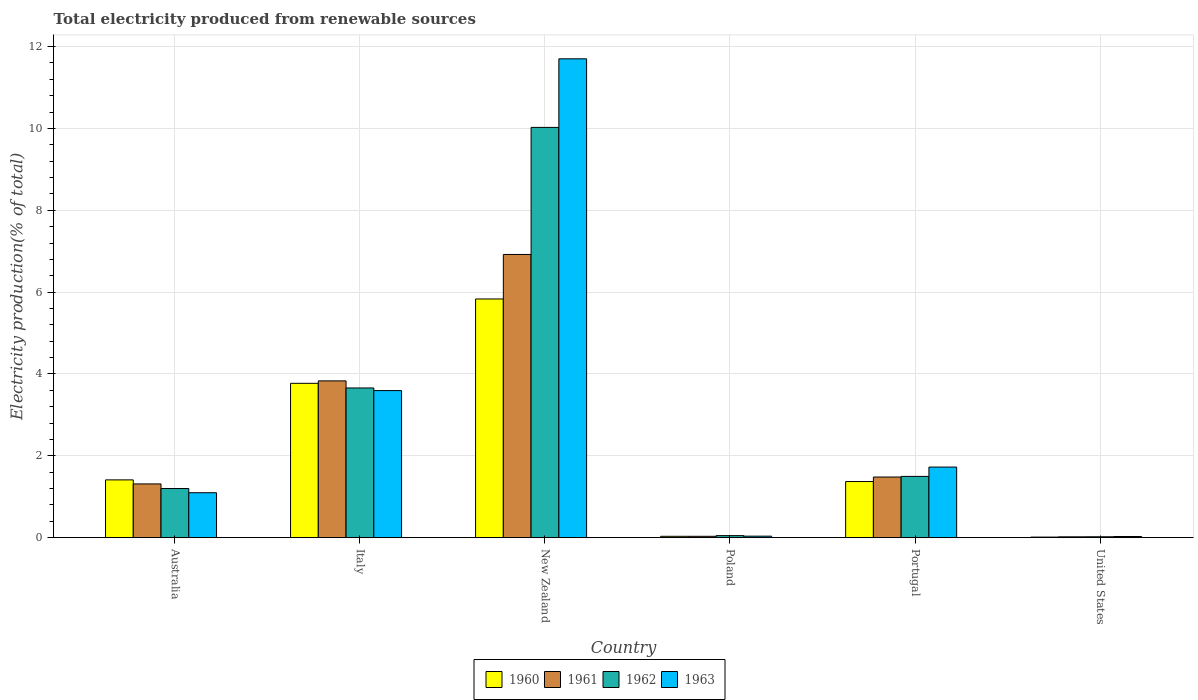How many groups of bars are there?
Make the answer very short. 6. Are the number of bars on each tick of the X-axis equal?
Ensure brevity in your answer.  Yes. How many bars are there on the 5th tick from the left?
Provide a short and direct response. 4. How many bars are there on the 2nd tick from the right?
Your response must be concise. 4. What is the label of the 4th group of bars from the left?
Your answer should be compact. Poland. What is the total electricity produced in 1962 in Poland?
Provide a short and direct response. 0.05. Across all countries, what is the maximum total electricity produced in 1963?
Make the answer very short. 11.7. Across all countries, what is the minimum total electricity produced in 1960?
Offer a terse response. 0.02. In which country was the total electricity produced in 1960 maximum?
Offer a terse response. New Zealand. In which country was the total electricity produced in 1960 minimum?
Keep it short and to the point. United States. What is the total total electricity produced in 1961 in the graph?
Keep it short and to the point. 13.6. What is the difference between the total electricity produced in 1963 in Australia and that in United States?
Offer a very short reply. 1.07. What is the difference between the total electricity produced in 1960 in Australia and the total electricity produced in 1962 in Poland?
Offer a terse response. 1.36. What is the average total electricity produced in 1961 per country?
Offer a terse response. 2.27. What is the difference between the total electricity produced of/in 1962 and total electricity produced of/in 1961 in Poland?
Your answer should be compact. 0.02. What is the ratio of the total electricity produced in 1963 in Italy to that in New Zealand?
Provide a short and direct response. 0.31. Is the total electricity produced in 1963 in Australia less than that in New Zealand?
Give a very brief answer. Yes. What is the difference between the highest and the second highest total electricity produced in 1963?
Provide a succinct answer. 1.87. What is the difference between the highest and the lowest total electricity produced in 1961?
Provide a short and direct response. 6.9. In how many countries, is the total electricity produced in 1963 greater than the average total electricity produced in 1963 taken over all countries?
Your answer should be compact. 2. Is it the case that in every country, the sum of the total electricity produced in 1963 and total electricity produced in 1961 is greater than the sum of total electricity produced in 1962 and total electricity produced in 1960?
Your response must be concise. No. How many bars are there?
Your response must be concise. 24. Are all the bars in the graph horizontal?
Provide a short and direct response. No. Does the graph contain any zero values?
Your answer should be very brief. No. What is the title of the graph?
Provide a succinct answer. Total electricity produced from renewable sources. Does "1993" appear as one of the legend labels in the graph?
Make the answer very short. No. What is the label or title of the Y-axis?
Ensure brevity in your answer.  Electricity production(% of total). What is the Electricity production(% of total) in 1960 in Australia?
Give a very brief answer. 1.41. What is the Electricity production(% of total) of 1961 in Australia?
Your answer should be compact. 1.31. What is the Electricity production(% of total) in 1962 in Australia?
Keep it short and to the point. 1.2. What is the Electricity production(% of total) of 1963 in Australia?
Give a very brief answer. 1.1. What is the Electricity production(% of total) in 1960 in Italy?
Keep it short and to the point. 3.77. What is the Electricity production(% of total) in 1961 in Italy?
Ensure brevity in your answer.  3.83. What is the Electricity production(% of total) in 1962 in Italy?
Your answer should be very brief. 3.66. What is the Electricity production(% of total) in 1963 in Italy?
Your response must be concise. 3.59. What is the Electricity production(% of total) in 1960 in New Zealand?
Keep it short and to the point. 5.83. What is the Electricity production(% of total) of 1961 in New Zealand?
Your answer should be compact. 6.92. What is the Electricity production(% of total) in 1962 in New Zealand?
Your answer should be compact. 10.02. What is the Electricity production(% of total) in 1963 in New Zealand?
Your response must be concise. 11.7. What is the Electricity production(% of total) in 1960 in Poland?
Provide a short and direct response. 0.03. What is the Electricity production(% of total) in 1961 in Poland?
Offer a very short reply. 0.03. What is the Electricity production(% of total) in 1962 in Poland?
Ensure brevity in your answer.  0.05. What is the Electricity production(% of total) in 1963 in Poland?
Ensure brevity in your answer.  0.04. What is the Electricity production(% of total) of 1960 in Portugal?
Your answer should be very brief. 1.37. What is the Electricity production(% of total) of 1961 in Portugal?
Ensure brevity in your answer.  1.48. What is the Electricity production(% of total) in 1962 in Portugal?
Your answer should be very brief. 1.5. What is the Electricity production(% of total) in 1963 in Portugal?
Your answer should be compact. 1.73. What is the Electricity production(% of total) of 1960 in United States?
Give a very brief answer. 0.02. What is the Electricity production(% of total) in 1961 in United States?
Your response must be concise. 0.02. What is the Electricity production(% of total) of 1962 in United States?
Offer a very short reply. 0.02. What is the Electricity production(% of total) of 1963 in United States?
Keep it short and to the point. 0.03. Across all countries, what is the maximum Electricity production(% of total) in 1960?
Your answer should be compact. 5.83. Across all countries, what is the maximum Electricity production(% of total) of 1961?
Keep it short and to the point. 6.92. Across all countries, what is the maximum Electricity production(% of total) in 1962?
Ensure brevity in your answer.  10.02. Across all countries, what is the maximum Electricity production(% of total) in 1963?
Your answer should be very brief. 11.7. Across all countries, what is the minimum Electricity production(% of total) of 1960?
Keep it short and to the point. 0.02. Across all countries, what is the minimum Electricity production(% of total) of 1961?
Ensure brevity in your answer.  0.02. Across all countries, what is the minimum Electricity production(% of total) of 1962?
Give a very brief answer. 0.02. Across all countries, what is the minimum Electricity production(% of total) of 1963?
Your answer should be very brief. 0.03. What is the total Electricity production(% of total) of 1960 in the graph?
Provide a succinct answer. 12.44. What is the total Electricity production(% of total) in 1961 in the graph?
Your response must be concise. 13.6. What is the total Electricity production(% of total) of 1962 in the graph?
Offer a terse response. 16.46. What is the total Electricity production(% of total) in 1963 in the graph?
Your response must be concise. 18.19. What is the difference between the Electricity production(% of total) in 1960 in Australia and that in Italy?
Provide a succinct answer. -2.36. What is the difference between the Electricity production(% of total) in 1961 in Australia and that in Italy?
Provide a short and direct response. -2.52. What is the difference between the Electricity production(% of total) of 1962 in Australia and that in Italy?
Your answer should be very brief. -2.46. What is the difference between the Electricity production(% of total) in 1963 in Australia and that in Italy?
Offer a terse response. -2.5. What is the difference between the Electricity production(% of total) of 1960 in Australia and that in New Zealand?
Your answer should be compact. -4.42. What is the difference between the Electricity production(% of total) of 1961 in Australia and that in New Zealand?
Ensure brevity in your answer.  -5.61. What is the difference between the Electricity production(% of total) in 1962 in Australia and that in New Zealand?
Provide a succinct answer. -8.82. What is the difference between the Electricity production(% of total) in 1963 in Australia and that in New Zealand?
Provide a short and direct response. -10.6. What is the difference between the Electricity production(% of total) in 1960 in Australia and that in Poland?
Your response must be concise. 1.38. What is the difference between the Electricity production(% of total) of 1961 in Australia and that in Poland?
Give a very brief answer. 1.28. What is the difference between the Electricity production(% of total) in 1962 in Australia and that in Poland?
Your answer should be compact. 1.15. What is the difference between the Electricity production(% of total) of 1963 in Australia and that in Poland?
Your answer should be compact. 1.06. What is the difference between the Electricity production(% of total) in 1960 in Australia and that in Portugal?
Give a very brief answer. 0.04. What is the difference between the Electricity production(% of total) in 1961 in Australia and that in Portugal?
Provide a succinct answer. -0.17. What is the difference between the Electricity production(% of total) in 1962 in Australia and that in Portugal?
Provide a succinct answer. -0.3. What is the difference between the Electricity production(% of total) in 1963 in Australia and that in Portugal?
Your answer should be compact. -0.63. What is the difference between the Electricity production(% of total) of 1960 in Australia and that in United States?
Keep it short and to the point. 1.4. What is the difference between the Electricity production(% of total) in 1961 in Australia and that in United States?
Your response must be concise. 1.29. What is the difference between the Electricity production(% of total) in 1962 in Australia and that in United States?
Offer a terse response. 1.18. What is the difference between the Electricity production(% of total) of 1963 in Australia and that in United States?
Offer a very short reply. 1.07. What is the difference between the Electricity production(% of total) in 1960 in Italy and that in New Zealand?
Provide a succinct answer. -2.06. What is the difference between the Electricity production(% of total) in 1961 in Italy and that in New Zealand?
Your answer should be very brief. -3.09. What is the difference between the Electricity production(% of total) in 1962 in Italy and that in New Zealand?
Keep it short and to the point. -6.37. What is the difference between the Electricity production(% of total) in 1963 in Italy and that in New Zealand?
Your response must be concise. -8.11. What is the difference between the Electricity production(% of total) of 1960 in Italy and that in Poland?
Give a very brief answer. 3.74. What is the difference between the Electricity production(% of total) of 1961 in Italy and that in Poland?
Your response must be concise. 3.8. What is the difference between the Electricity production(% of total) of 1962 in Italy and that in Poland?
Offer a terse response. 3.61. What is the difference between the Electricity production(% of total) of 1963 in Italy and that in Poland?
Give a very brief answer. 3.56. What is the difference between the Electricity production(% of total) of 1960 in Italy and that in Portugal?
Your response must be concise. 2.4. What is the difference between the Electricity production(% of total) of 1961 in Italy and that in Portugal?
Provide a succinct answer. 2.35. What is the difference between the Electricity production(% of total) in 1962 in Italy and that in Portugal?
Offer a very short reply. 2.16. What is the difference between the Electricity production(% of total) of 1963 in Italy and that in Portugal?
Your answer should be compact. 1.87. What is the difference between the Electricity production(% of total) of 1960 in Italy and that in United States?
Provide a succinct answer. 3.76. What is the difference between the Electricity production(% of total) of 1961 in Italy and that in United States?
Ensure brevity in your answer.  3.81. What is the difference between the Electricity production(% of total) in 1962 in Italy and that in United States?
Make the answer very short. 3.64. What is the difference between the Electricity production(% of total) in 1963 in Italy and that in United States?
Your answer should be very brief. 3.56. What is the difference between the Electricity production(% of total) of 1960 in New Zealand and that in Poland?
Offer a terse response. 5.8. What is the difference between the Electricity production(% of total) in 1961 in New Zealand and that in Poland?
Make the answer very short. 6.89. What is the difference between the Electricity production(% of total) in 1962 in New Zealand and that in Poland?
Offer a terse response. 9.97. What is the difference between the Electricity production(% of total) in 1963 in New Zealand and that in Poland?
Provide a short and direct response. 11.66. What is the difference between the Electricity production(% of total) in 1960 in New Zealand and that in Portugal?
Keep it short and to the point. 4.46. What is the difference between the Electricity production(% of total) in 1961 in New Zealand and that in Portugal?
Your response must be concise. 5.44. What is the difference between the Electricity production(% of total) in 1962 in New Zealand and that in Portugal?
Your response must be concise. 8.53. What is the difference between the Electricity production(% of total) in 1963 in New Zealand and that in Portugal?
Your answer should be very brief. 9.97. What is the difference between the Electricity production(% of total) in 1960 in New Zealand and that in United States?
Offer a very short reply. 5.82. What is the difference between the Electricity production(% of total) of 1961 in New Zealand and that in United States?
Provide a succinct answer. 6.9. What is the difference between the Electricity production(% of total) of 1962 in New Zealand and that in United States?
Keep it short and to the point. 10. What is the difference between the Electricity production(% of total) of 1963 in New Zealand and that in United States?
Give a very brief answer. 11.67. What is the difference between the Electricity production(% of total) of 1960 in Poland and that in Portugal?
Provide a succinct answer. -1.34. What is the difference between the Electricity production(% of total) in 1961 in Poland and that in Portugal?
Your answer should be very brief. -1.45. What is the difference between the Electricity production(% of total) of 1962 in Poland and that in Portugal?
Your response must be concise. -1.45. What is the difference between the Electricity production(% of total) of 1963 in Poland and that in Portugal?
Offer a terse response. -1.69. What is the difference between the Electricity production(% of total) of 1960 in Poland and that in United States?
Your answer should be compact. 0.02. What is the difference between the Electricity production(% of total) of 1961 in Poland and that in United States?
Your answer should be very brief. 0.01. What is the difference between the Electricity production(% of total) in 1962 in Poland and that in United States?
Your answer should be very brief. 0.03. What is the difference between the Electricity production(% of total) in 1963 in Poland and that in United States?
Your answer should be compact. 0.01. What is the difference between the Electricity production(% of total) in 1960 in Portugal and that in United States?
Your answer should be compact. 1.36. What is the difference between the Electricity production(% of total) in 1961 in Portugal and that in United States?
Keep it short and to the point. 1.46. What is the difference between the Electricity production(% of total) of 1962 in Portugal and that in United States?
Offer a terse response. 1.48. What is the difference between the Electricity production(% of total) in 1963 in Portugal and that in United States?
Offer a very short reply. 1.7. What is the difference between the Electricity production(% of total) in 1960 in Australia and the Electricity production(% of total) in 1961 in Italy?
Provide a succinct answer. -2.42. What is the difference between the Electricity production(% of total) of 1960 in Australia and the Electricity production(% of total) of 1962 in Italy?
Offer a terse response. -2.25. What is the difference between the Electricity production(% of total) of 1960 in Australia and the Electricity production(% of total) of 1963 in Italy?
Your answer should be compact. -2.18. What is the difference between the Electricity production(% of total) of 1961 in Australia and the Electricity production(% of total) of 1962 in Italy?
Provide a short and direct response. -2.34. What is the difference between the Electricity production(% of total) of 1961 in Australia and the Electricity production(% of total) of 1963 in Italy?
Your response must be concise. -2.28. What is the difference between the Electricity production(% of total) of 1962 in Australia and the Electricity production(% of total) of 1963 in Italy?
Make the answer very short. -2.39. What is the difference between the Electricity production(% of total) in 1960 in Australia and the Electricity production(% of total) in 1961 in New Zealand?
Provide a short and direct response. -5.51. What is the difference between the Electricity production(% of total) in 1960 in Australia and the Electricity production(% of total) in 1962 in New Zealand?
Offer a very short reply. -8.61. What is the difference between the Electricity production(% of total) of 1960 in Australia and the Electricity production(% of total) of 1963 in New Zealand?
Your response must be concise. -10.29. What is the difference between the Electricity production(% of total) in 1961 in Australia and the Electricity production(% of total) in 1962 in New Zealand?
Your response must be concise. -8.71. What is the difference between the Electricity production(% of total) of 1961 in Australia and the Electricity production(% of total) of 1963 in New Zealand?
Offer a very short reply. -10.39. What is the difference between the Electricity production(% of total) in 1962 in Australia and the Electricity production(% of total) in 1963 in New Zealand?
Provide a short and direct response. -10.5. What is the difference between the Electricity production(% of total) of 1960 in Australia and the Electricity production(% of total) of 1961 in Poland?
Offer a very short reply. 1.38. What is the difference between the Electricity production(% of total) of 1960 in Australia and the Electricity production(% of total) of 1962 in Poland?
Provide a succinct answer. 1.36. What is the difference between the Electricity production(% of total) in 1960 in Australia and the Electricity production(% of total) in 1963 in Poland?
Ensure brevity in your answer.  1.37. What is the difference between the Electricity production(% of total) of 1961 in Australia and the Electricity production(% of total) of 1962 in Poland?
Provide a short and direct response. 1.26. What is the difference between the Electricity production(% of total) in 1961 in Australia and the Electricity production(% of total) in 1963 in Poland?
Provide a succinct answer. 1.28. What is the difference between the Electricity production(% of total) in 1962 in Australia and the Electricity production(% of total) in 1963 in Poland?
Offer a terse response. 1.16. What is the difference between the Electricity production(% of total) in 1960 in Australia and the Electricity production(% of total) in 1961 in Portugal?
Offer a very short reply. -0.07. What is the difference between the Electricity production(% of total) in 1960 in Australia and the Electricity production(% of total) in 1962 in Portugal?
Give a very brief answer. -0.09. What is the difference between the Electricity production(% of total) of 1960 in Australia and the Electricity production(% of total) of 1963 in Portugal?
Your answer should be compact. -0.31. What is the difference between the Electricity production(% of total) of 1961 in Australia and the Electricity production(% of total) of 1962 in Portugal?
Provide a succinct answer. -0.18. What is the difference between the Electricity production(% of total) of 1961 in Australia and the Electricity production(% of total) of 1963 in Portugal?
Offer a very short reply. -0.41. What is the difference between the Electricity production(% of total) in 1962 in Australia and the Electricity production(% of total) in 1963 in Portugal?
Make the answer very short. -0.52. What is the difference between the Electricity production(% of total) in 1960 in Australia and the Electricity production(% of total) in 1961 in United States?
Your answer should be very brief. 1.39. What is the difference between the Electricity production(% of total) in 1960 in Australia and the Electricity production(% of total) in 1962 in United States?
Offer a very short reply. 1.39. What is the difference between the Electricity production(% of total) of 1960 in Australia and the Electricity production(% of total) of 1963 in United States?
Ensure brevity in your answer.  1.38. What is the difference between the Electricity production(% of total) in 1961 in Australia and the Electricity production(% of total) in 1962 in United States?
Provide a short and direct response. 1.29. What is the difference between the Electricity production(% of total) of 1961 in Australia and the Electricity production(% of total) of 1963 in United States?
Offer a terse response. 1.28. What is the difference between the Electricity production(% of total) in 1962 in Australia and the Electricity production(% of total) in 1963 in United States?
Provide a succinct answer. 1.17. What is the difference between the Electricity production(% of total) in 1960 in Italy and the Electricity production(% of total) in 1961 in New Zealand?
Provide a short and direct response. -3.15. What is the difference between the Electricity production(% of total) of 1960 in Italy and the Electricity production(% of total) of 1962 in New Zealand?
Give a very brief answer. -6.25. What is the difference between the Electricity production(% of total) in 1960 in Italy and the Electricity production(% of total) in 1963 in New Zealand?
Provide a short and direct response. -7.93. What is the difference between the Electricity production(% of total) of 1961 in Italy and the Electricity production(% of total) of 1962 in New Zealand?
Offer a very short reply. -6.19. What is the difference between the Electricity production(% of total) of 1961 in Italy and the Electricity production(% of total) of 1963 in New Zealand?
Ensure brevity in your answer.  -7.87. What is the difference between the Electricity production(% of total) in 1962 in Italy and the Electricity production(% of total) in 1963 in New Zealand?
Make the answer very short. -8.04. What is the difference between the Electricity production(% of total) in 1960 in Italy and the Electricity production(% of total) in 1961 in Poland?
Give a very brief answer. 3.74. What is the difference between the Electricity production(% of total) of 1960 in Italy and the Electricity production(% of total) of 1962 in Poland?
Your answer should be compact. 3.72. What is the difference between the Electricity production(% of total) in 1960 in Italy and the Electricity production(% of total) in 1963 in Poland?
Give a very brief answer. 3.73. What is the difference between the Electricity production(% of total) of 1961 in Italy and the Electricity production(% of total) of 1962 in Poland?
Your response must be concise. 3.78. What is the difference between the Electricity production(% of total) in 1961 in Italy and the Electricity production(% of total) in 1963 in Poland?
Provide a short and direct response. 3.79. What is the difference between the Electricity production(% of total) of 1962 in Italy and the Electricity production(% of total) of 1963 in Poland?
Ensure brevity in your answer.  3.62. What is the difference between the Electricity production(% of total) in 1960 in Italy and the Electricity production(% of total) in 1961 in Portugal?
Ensure brevity in your answer.  2.29. What is the difference between the Electricity production(% of total) in 1960 in Italy and the Electricity production(% of total) in 1962 in Portugal?
Give a very brief answer. 2.27. What is the difference between the Electricity production(% of total) in 1960 in Italy and the Electricity production(% of total) in 1963 in Portugal?
Provide a succinct answer. 2.05. What is the difference between the Electricity production(% of total) in 1961 in Italy and the Electricity production(% of total) in 1962 in Portugal?
Give a very brief answer. 2.33. What is the difference between the Electricity production(% of total) of 1961 in Italy and the Electricity production(% of total) of 1963 in Portugal?
Keep it short and to the point. 2.11. What is the difference between the Electricity production(% of total) in 1962 in Italy and the Electricity production(% of total) in 1963 in Portugal?
Provide a short and direct response. 1.93. What is the difference between the Electricity production(% of total) of 1960 in Italy and the Electricity production(% of total) of 1961 in United States?
Ensure brevity in your answer.  3.75. What is the difference between the Electricity production(% of total) in 1960 in Italy and the Electricity production(% of total) in 1962 in United States?
Offer a very short reply. 3.75. What is the difference between the Electricity production(% of total) in 1960 in Italy and the Electricity production(% of total) in 1963 in United States?
Give a very brief answer. 3.74. What is the difference between the Electricity production(% of total) in 1961 in Italy and the Electricity production(% of total) in 1962 in United States?
Give a very brief answer. 3.81. What is the difference between the Electricity production(% of total) in 1961 in Italy and the Electricity production(% of total) in 1963 in United States?
Your response must be concise. 3.8. What is the difference between the Electricity production(% of total) of 1962 in Italy and the Electricity production(% of total) of 1963 in United States?
Your answer should be compact. 3.63. What is the difference between the Electricity production(% of total) of 1960 in New Zealand and the Electricity production(% of total) of 1961 in Poland?
Give a very brief answer. 5.8. What is the difference between the Electricity production(% of total) in 1960 in New Zealand and the Electricity production(% of total) in 1962 in Poland?
Keep it short and to the point. 5.78. What is the difference between the Electricity production(% of total) in 1960 in New Zealand and the Electricity production(% of total) in 1963 in Poland?
Keep it short and to the point. 5.79. What is the difference between the Electricity production(% of total) of 1961 in New Zealand and the Electricity production(% of total) of 1962 in Poland?
Provide a short and direct response. 6.87. What is the difference between the Electricity production(% of total) in 1961 in New Zealand and the Electricity production(% of total) in 1963 in Poland?
Offer a very short reply. 6.88. What is the difference between the Electricity production(% of total) of 1962 in New Zealand and the Electricity production(% of total) of 1963 in Poland?
Give a very brief answer. 9.99. What is the difference between the Electricity production(% of total) in 1960 in New Zealand and the Electricity production(% of total) in 1961 in Portugal?
Provide a short and direct response. 4.35. What is the difference between the Electricity production(% of total) in 1960 in New Zealand and the Electricity production(% of total) in 1962 in Portugal?
Offer a very short reply. 4.33. What is the difference between the Electricity production(% of total) in 1960 in New Zealand and the Electricity production(% of total) in 1963 in Portugal?
Offer a very short reply. 4.11. What is the difference between the Electricity production(% of total) in 1961 in New Zealand and the Electricity production(% of total) in 1962 in Portugal?
Your answer should be compact. 5.42. What is the difference between the Electricity production(% of total) of 1961 in New Zealand and the Electricity production(% of total) of 1963 in Portugal?
Provide a succinct answer. 5.19. What is the difference between the Electricity production(% of total) of 1962 in New Zealand and the Electricity production(% of total) of 1963 in Portugal?
Your answer should be compact. 8.3. What is the difference between the Electricity production(% of total) in 1960 in New Zealand and the Electricity production(% of total) in 1961 in United States?
Offer a terse response. 5.81. What is the difference between the Electricity production(% of total) of 1960 in New Zealand and the Electricity production(% of total) of 1962 in United States?
Provide a succinct answer. 5.81. What is the difference between the Electricity production(% of total) in 1960 in New Zealand and the Electricity production(% of total) in 1963 in United States?
Provide a succinct answer. 5.8. What is the difference between the Electricity production(% of total) of 1961 in New Zealand and the Electricity production(% of total) of 1962 in United States?
Ensure brevity in your answer.  6.9. What is the difference between the Electricity production(% of total) of 1961 in New Zealand and the Electricity production(% of total) of 1963 in United States?
Offer a terse response. 6.89. What is the difference between the Electricity production(% of total) in 1962 in New Zealand and the Electricity production(% of total) in 1963 in United States?
Offer a very short reply. 10. What is the difference between the Electricity production(% of total) in 1960 in Poland and the Electricity production(% of total) in 1961 in Portugal?
Offer a very short reply. -1.45. What is the difference between the Electricity production(% of total) of 1960 in Poland and the Electricity production(% of total) of 1962 in Portugal?
Your answer should be very brief. -1.46. What is the difference between the Electricity production(% of total) of 1960 in Poland and the Electricity production(% of total) of 1963 in Portugal?
Keep it short and to the point. -1.69. What is the difference between the Electricity production(% of total) in 1961 in Poland and the Electricity production(% of total) in 1962 in Portugal?
Make the answer very short. -1.46. What is the difference between the Electricity production(% of total) of 1961 in Poland and the Electricity production(% of total) of 1963 in Portugal?
Offer a terse response. -1.69. What is the difference between the Electricity production(% of total) of 1962 in Poland and the Electricity production(% of total) of 1963 in Portugal?
Give a very brief answer. -1.67. What is the difference between the Electricity production(% of total) of 1960 in Poland and the Electricity production(% of total) of 1961 in United States?
Provide a succinct answer. 0.01. What is the difference between the Electricity production(% of total) in 1960 in Poland and the Electricity production(% of total) in 1962 in United States?
Your response must be concise. 0.01. What is the difference between the Electricity production(% of total) in 1960 in Poland and the Electricity production(% of total) in 1963 in United States?
Offer a very short reply. 0. What is the difference between the Electricity production(% of total) of 1961 in Poland and the Electricity production(% of total) of 1962 in United States?
Make the answer very short. 0.01. What is the difference between the Electricity production(% of total) in 1961 in Poland and the Electricity production(% of total) in 1963 in United States?
Ensure brevity in your answer.  0. What is the difference between the Electricity production(% of total) in 1962 in Poland and the Electricity production(% of total) in 1963 in United States?
Provide a succinct answer. 0.02. What is the difference between the Electricity production(% of total) of 1960 in Portugal and the Electricity production(% of total) of 1961 in United States?
Provide a succinct answer. 1.35. What is the difference between the Electricity production(% of total) in 1960 in Portugal and the Electricity production(% of total) in 1962 in United States?
Keep it short and to the point. 1.35. What is the difference between the Electricity production(% of total) of 1960 in Portugal and the Electricity production(% of total) of 1963 in United States?
Give a very brief answer. 1.34. What is the difference between the Electricity production(% of total) in 1961 in Portugal and the Electricity production(% of total) in 1962 in United States?
Offer a very short reply. 1.46. What is the difference between the Electricity production(% of total) of 1961 in Portugal and the Electricity production(% of total) of 1963 in United States?
Your answer should be compact. 1.45. What is the difference between the Electricity production(% of total) of 1962 in Portugal and the Electricity production(% of total) of 1963 in United States?
Make the answer very short. 1.47. What is the average Electricity production(% of total) of 1960 per country?
Your response must be concise. 2.07. What is the average Electricity production(% of total) of 1961 per country?
Provide a short and direct response. 2.27. What is the average Electricity production(% of total) of 1962 per country?
Your answer should be very brief. 2.74. What is the average Electricity production(% of total) in 1963 per country?
Your answer should be compact. 3.03. What is the difference between the Electricity production(% of total) in 1960 and Electricity production(% of total) in 1961 in Australia?
Your response must be concise. 0.1. What is the difference between the Electricity production(% of total) in 1960 and Electricity production(% of total) in 1962 in Australia?
Offer a terse response. 0.21. What is the difference between the Electricity production(% of total) in 1960 and Electricity production(% of total) in 1963 in Australia?
Provide a short and direct response. 0.31. What is the difference between the Electricity production(% of total) in 1961 and Electricity production(% of total) in 1962 in Australia?
Make the answer very short. 0.11. What is the difference between the Electricity production(% of total) in 1961 and Electricity production(% of total) in 1963 in Australia?
Provide a short and direct response. 0.21. What is the difference between the Electricity production(% of total) of 1962 and Electricity production(% of total) of 1963 in Australia?
Offer a terse response. 0.1. What is the difference between the Electricity production(% of total) of 1960 and Electricity production(% of total) of 1961 in Italy?
Your response must be concise. -0.06. What is the difference between the Electricity production(% of total) in 1960 and Electricity production(% of total) in 1962 in Italy?
Your answer should be very brief. 0.11. What is the difference between the Electricity production(% of total) of 1960 and Electricity production(% of total) of 1963 in Italy?
Your answer should be very brief. 0.18. What is the difference between the Electricity production(% of total) of 1961 and Electricity production(% of total) of 1962 in Italy?
Give a very brief answer. 0.17. What is the difference between the Electricity production(% of total) of 1961 and Electricity production(% of total) of 1963 in Italy?
Ensure brevity in your answer.  0.24. What is the difference between the Electricity production(% of total) of 1962 and Electricity production(% of total) of 1963 in Italy?
Give a very brief answer. 0.06. What is the difference between the Electricity production(% of total) of 1960 and Electricity production(% of total) of 1961 in New Zealand?
Keep it short and to the point. -1.09. What is the difference between the Electricity production(% of total) of 1960 and Electricity production(% of total) of 1962 in New Zealand?
Make the answer very short. -4.19. What is the difference between the Electricity production(% of total) of 1960 and Electricity production(% of total) of 1963 in New Zealand?
Provide a short and direct response. -5.87. What is the difference between the Electricity production(% of total) of 1961 and Electricity production(% of total) of 1962 in New Zealand?
Offer a very short reply. -3.1. What is the difference between the Electricity production(% of total) in 1961 and Electricity production(% of total) in 1963 in New Zealand?
Keep it short and to the point. -4.78. What is the difference between the Electricity production(% of total) in 1962 and Electricity production(% of total) in 1963 in New Zealand?
Offer a terse response. -1.68. What is the difference between the Electricity production(% of total) of 1960 and Electricity production(% of total) of 1962 in Poland?
Offer a terse response. -0.02. What is the difference between the Electricity production(% of total) in 1960 and Electricity production(% of total) in 1963 in Poland?
Make the answer very short. -0. What is the difference between the Electricity production(% of total) in 1961 and Electricity production(% of total) in 1962 in Poland?
Give a very brief answer. -0.02. What is the difference between the Electricity production(% of total) of 1961 and Electricity production(% of total) of 1963 in Poland?
Your answer should be very brief. -0. What is the difference between the Electricity production(% of total) of 1962 and Electricity production(% of total) of 1963 in Poland?
Your answer should be compact. 0.01. What is the difference between the Electricity production(% of total) of 1960 and Electricity production(% of total) of 1961 in Portugal?
Your response must be concise. -0.11. What is the difference between the Electricity production(% of total) of 1960 and Electricity production(% of total) of 1962 in Portugal?
Offer a terse response. -0.13. What is the difference between the Electricity production(% of total) of 1960 and Electricity production(% of total) of 1963 in Portugal?
Offer a very short reply. -0.35. What is the difference between the Electricity production(% of total) in 1961 and Electricity production(% of total) in 1962 in Portugal?
Your answer should be very brief. -0.02. What is the difference between the Electricity production(% of total) in 1961 and Electricity production(% of total) in 1963 in Portugal?
Provide a short and direct response. -0.24. What is the difference between the Electricity production(% of total) of 1962 and Electricity production(% of total) of 1963 in Portugal?
Your response must be concise. -0.23. What is the difference between the Electricity production(% of total) of 1960 and Electricity production(% of total) of 1961 in United States?
Provide a succinct answer. -0.01. What is the difference between the Electricity production(% of total) in 1960 and Electricity production(% of total) in 1962 in United States?
Provide a succinct answer. -0.01. What is the difference between the Electricity production(% of total) of 1960 and Electricity production(% of total) of 1963 in United States?
Provide a succinct answer. -0.01. What is the difference between the Electricity production(% of total) of 1961 and Electricity production(% of total) of 1962 in United States?
Provide a succinct answer. -0. What is the difference between the Electricity production(% of total) of 1961 and Electricity production(% of total) of 1963 in United States?
Your response must be concise. -0.01. What is the difference between the Electricity production(% of total) in 1962 and Electricity production(% of total) in 1963 in United States?
Your answer should be compact. -0.01. What is the ratio of the Electricity production(% of total) of 1960 in Australia to that in Italy?
Ensure brevity in your answer.  0.37. What is the ratio of the Electricity production(% of total) in 1961 in Australia to that in Italy?
Offer a very short reply. 0.34. What is the ratio of the Electricity production(% of total) in 1962 in Australia to that in Italy?
Make the answer very short. 0.33. What is the ratio of the Electricity production(% of total) of 1963 in Australia to that in Italy?
Your response must be concise. 0.31. What is the ratio of the Electricity production(% of total) of 1960 in Australia to that in New Zealand?
Make the answer very short. 0.24. What is the ratio of the Electricity production(% of total) of 1961 in Australia to that in New Zealand?
Provide a short and direct response. 0.19. What is the ratio of the Electricity production(% of total) of 1962 in Australia to that in New Zealand?
Offer a terse response. 0.12. What is the ratio of the Electricity production(% of total) in 1963 in Australia to that in New Zealand?
Ensure brevity in your answer.  0.09. What is the ratio of the Electricity production(% of total) of 1960 in Australia to that in Poland?
Your answer should be compact. 41.37. What is the ratio of the Electricity production(% of total) of 1961 in Australia to that in Poland?
Your answer should be very brief. 38.51. What is the ratio of the Electricity production(% of total) of 1962 in Australia to that in Poland?
Provide a short and direct response. 23.61. What is the ratio of the Electricity production(% of total) of 1963 in Australia to that in Poland?
Keep it short and to the point. 29. What is the ratio of the Electricity production(% of total) of 1960 in Australia to that in Portugal?
Ensure brevity in your answer.  1.03. What is the ratio of the Electricity production(% of total) of 1961 in Australia to that in Portugal?
Provide a short and direct response. 0.89. What is the ratio of the Electricity production(% of total) of 1962 in Australia to that in Portugal?
Your answer should be compact. 0.8. What is the ratio of the Electricity production(% of total) of 1963 in Australia to that in Portugal?
Provide a succinct answer. 0.64. What is the ratio of the Electricity production(% of total) in 1960 in Australia to that in United States?
Provide a short and direct response. 92.6. What is the ratio of the Electricity production(% of total) in 1961 in Australia to that in United States?
Ensure brevity in your answer.  61. What is the ratio of the Electricity production(% of total) of 1962 in Australia to that in United States?
Ensure brevity in your answer.  52.74. What is the ratio of the Electricity production(% of total) of 1963 in Australia to that in United States?
Offer a very short reply. 37.34. What is the ratio of the Electricity production(% of total) of 1960 in Italy to that in New Zealand?
Offer a very short reply. 0.65. What is the ratio of the Electricity production(% of total) of 1961 in Italy to that in New Zealand?
Your answer should be very brief. 0.55. What is the ratio of the Electricity production(% of total) in 1962 in Italy to that in New Zealand?
Your answer should be very brief. 0.36. What is the ratio of the Electricity production(% of total) of 1963 in Italy to that in New Zealand?
Ensure brevity in your answer.  0.31. What is the ratio of the Electricity production(% of total) of 1960 in Italy to that in Poland?
Provide a succinct answer. 110.45. What is the ratio of the Electricity production(% of total) in 1961 in Italy to that in Poland?
Provide a succinct answer. 112.3. What is the ratio of the Electricity production(% of total) of 1962 in Italy to that in Poland?
Ensure brevity in your answer.  71.88. What is the ratio of the Electricity production(% of total) of 1963 in Italy to that in Poland?
Provide a short and direct response. 94.84. What is the ratio of the Electricity production(% of total) in 1960 in Italy to that in Portugal?
Your answer should be very brief. 2.75. What is the ratio of the Electricity production(% of total) of 1961 in Italy to that in Portugal?
Your response must be concise. 2.58. What is the ratio of the Electricity production(% of total) in 1962 in Italy to that in Portugal?
Provide a short and direct response. 2.44. What is the ratio of the Electricity production(% of total) of 1963 in Italy to that in Portugal?
Offer a terse response. 2.08. What is the ratio of the Electricity production(% of total) in 1960 in Italy to that in United States?
Your answer should be very brief. 247.25. What is the ratio of the Electricity production(% of total) in 1961 in Italy to that in United States?
Your answer should be very brief. 177.87. What is the ratio of the Electricity production(% of total) of 1962 in Italy to that in United States?
Give a very brief answer. 160.56. What is the ratio of the Electricity production(% of total) of 1963 in Italy to that in United States?
Provide a succinct answer. 122.12. What is the ratio of the Electricity production(% of total) of 1960 in New Zealand to that in Poland?
Give a very brief answer. 170.79. What is the ratio of the Electricity production(% of total) of 1961 in New Zealand to that in Poland?
Your answer should be compact. 202.83. What is the ratio of the Electricity production(% of total) in 1962 in New Zealand to that in Poland?
Provide a short and direct response. 196.95. What is the ratio of the Electricity production(% of total) in 1963 in New Zealand to that in Poland?
Make the answer very short. 308.73. What is the ratio of the Electricity production(% of total) in 1960 in New Zealand to that in Portugal?
Ensure brevity in your answer.  4.25. What is the ratio of the Electricity production(% of total) of 1961 in New Zealand to that in Portugal?
Ensure brevity in your answer.  4.67. What is the ratio of the Electricity production(% of total) of 1962 in New Zealand to that in Portugal?
Offer a very short reply. 6.69. What is the ratio of the Electricity production(% of total) of 1963 in New Zealand to that in Portugal?
Your answer should be compact. 6.78. What is the ratio of the Electricity production(% of total) of 1960 in New Zealand to that in United States?
Your answer should be compact. 382.31. What is the ratio of the Electricity production(% of total) in 1961 in New Zealand to that in United States?
Your answer should be very brief. 321.25. What is the ratio of the Electricity production(% of total) in 1962 in New Zealand to that in United States?
Provide a short and direct response. 439.93. What is the ratio of the Electricity production(% of total) in 1963 in New Zealand to that in United States?
Give a very brief answer. 397.5. What is the ratio of the Electricity production(% of total) of 1960 in Poland to that in Portugal?
Provide a short and direct response. 0.02. What is the ratio of the Electricity production(% of total) of 1961 in Poland to that in Portugal?
Your response must be concise. 0.02. What is the ratio of the Electricity production(% of total) of 1962 in Poland to that in Portugal?
Your answer should be very brief. 0.03. What is the ratio of the Electricity production(% of total) in 1963 in Poland to that in Portugal?
Your answer should be very brief. 0.02. What is the ratio of the Electricity production(% of total) in 1960 in Poland to that in United States?
Offer a very short reply. 2.24. What is the ratio of the Electricity production(% of total) in 1961 in Poland to that in United States?
Offer a very short reply. 1.58. What is the ratio of the Electricity production(% of total) in 1962 in Poland to that in United States?
Offer a very short reply. 2.23. What is the ratio of the Electricity production(% of total) of 1963 in Poland to that in United States?
Offer a very short reply. 1.29. What is the ratio of the Electricity production(% of total) of 1960 in Portugal to that in United States?
Your response must be concise. 89.96. What is the ratio of the Electricity production(% of total) in 1961 in Portugal to that in United States?
Provide a succinct answer. 68.83. What is the ratio of the Electricity production(% of total) of 1962 in Portugal to that in United States?
Offer a very short reply. 65.74. What is the ratio of the Electricity production(% of total) of 1963 in Portugal to that in United States?
Your answer should be very brief. 58.63. What is the difference between the highest and the second highest Electricity production(% of total) of 1960?
Offer a terse response. 2.06. What is the difference between the highest and the second highest Electricity production(% of total) in 1961?
Make the answer very short. 3.09. What is the difference between the highest and the second highest Electricity production(% of total) of 1962?
Offer a terse response. 6.37. What is the difference between the highest and the second highest Electricity production(% of total) in 1963?
Your response must be concise. 8.11. What is the difference between the highest and the lowest Electricity production(% of total) of 1960?
Provide a short and direct response. 5.82. What is the difference between the highest and the lowest Electricity production(% of total) of 1961?
Offer a terse response. 6.9. What is the difference between the highest and the lowest Electricity production(% of total) of 1962?
Your answer should be compact. 10. What is the difference between the highest and the lowest Electricity production(% of total) in 1963?
Your response must be concise. 11.67. 